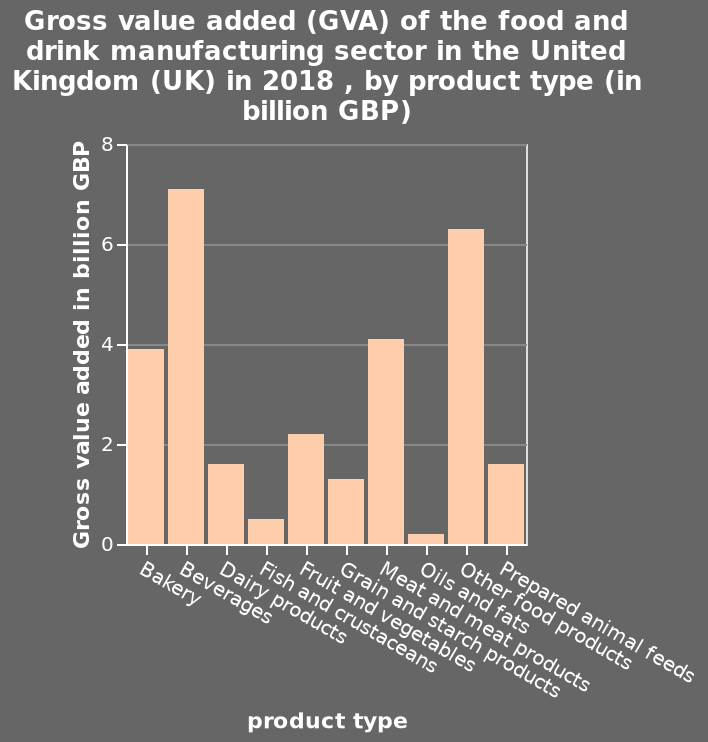<image>
What does the y-axis represent on the bar chart? The y-axis on the bar chart represents Gross value added in billion GBP. What is the product with the lowest GVA?  The product with the lowest GVA is oils and fats. 